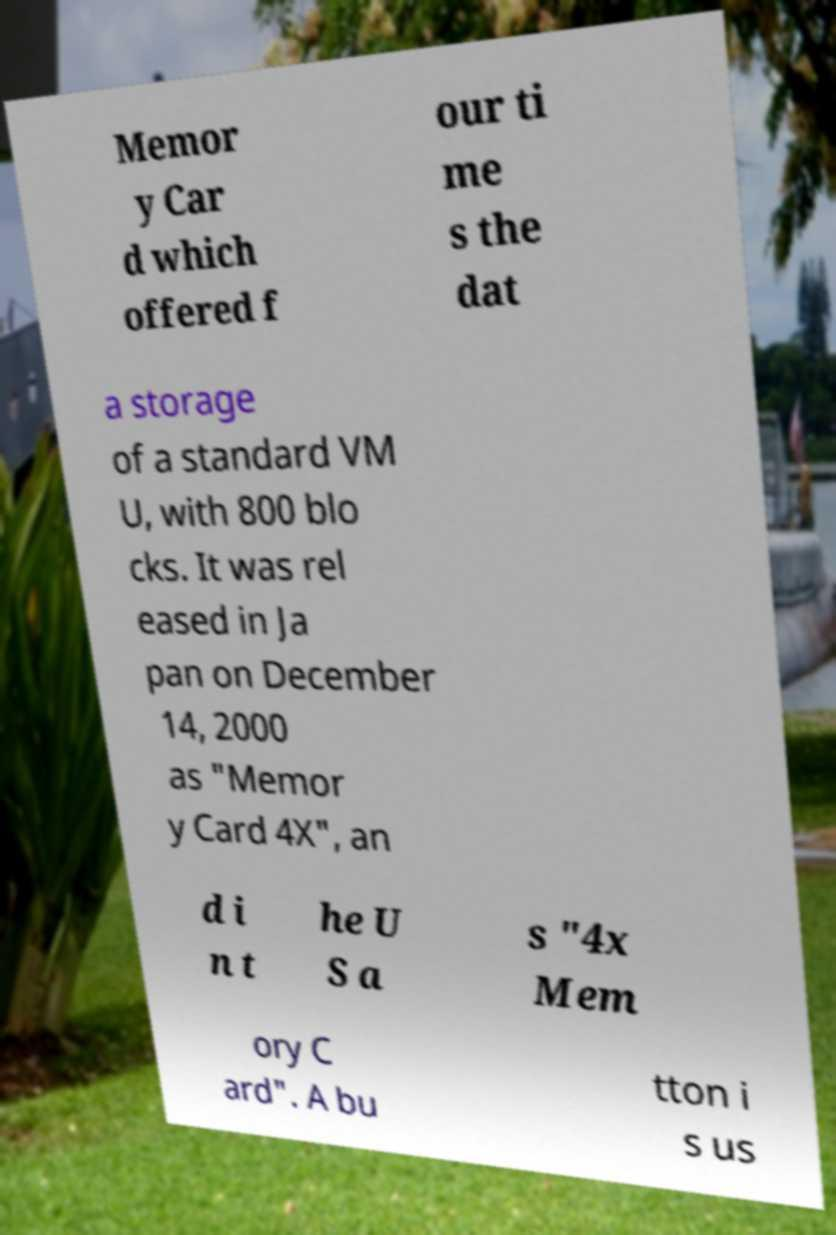I need the written content from this picture converted into text. Can you do that? Memor y Car d which offered f our ti me s the dat a storage of a standard VM U, with 800 blo cks. It was rel eased in Ja pan on December 14, 2000 as "Memor y Card 4X", an d i n t he U S a s "4x Mem ory C ard". A bu tton i s us 